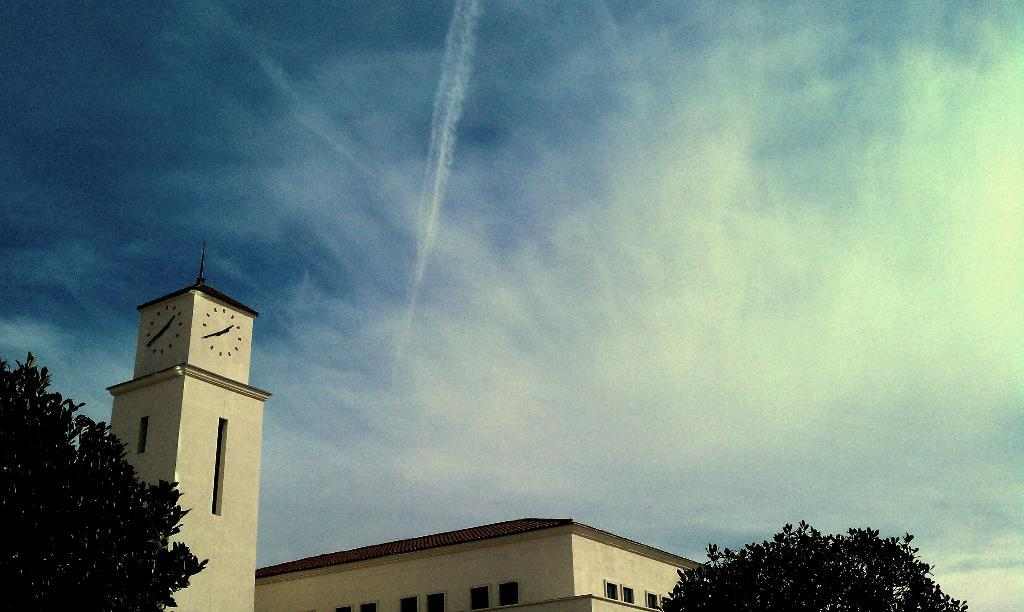What structure is located at the bottom of the image? There is a building at the bottom of the image. What type of vegetation is on the left side of the image? There are trees on the left side of the image. What feature can be seen on the steeple in the image? There is a clock on the steeple in the image. What type of vegetation is in the middle of the image? There are trees in the middle of the image. What is visible in the image besides the building and trees? The sky is visible in the image. What can be observed in the sky? Clouds are present in the sky. What type of underwear is hanging on the trees? There is no underwear present in the image; it features a building, trees, a steeple with a clock, and clouds in the sky. What boundary is visible in the image? There is no boundary visible in the image; it features a building, trees, a steeple with a clock, and clouds in the sky. 